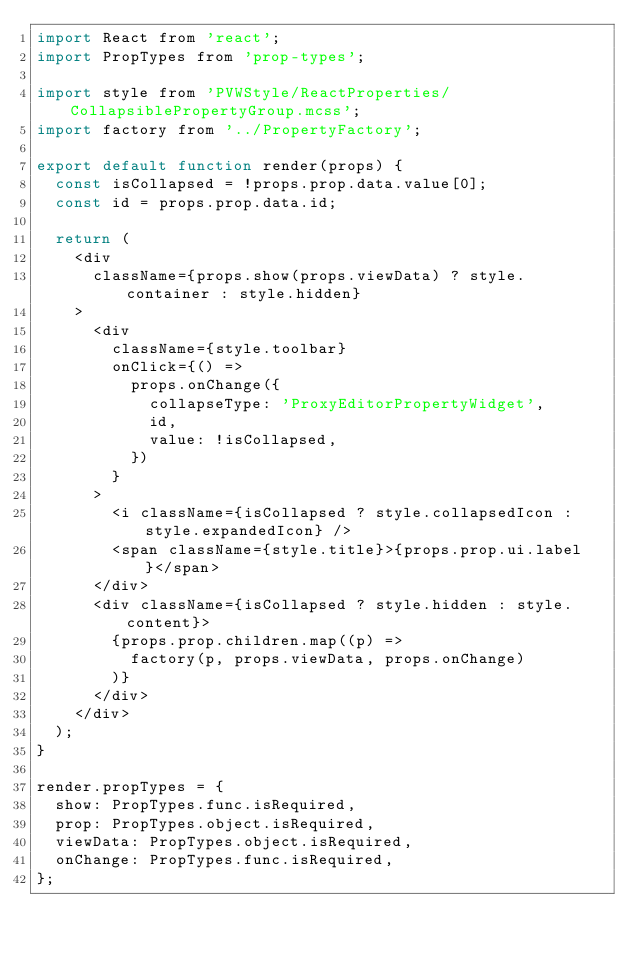Convert code to text. <code><loc_0><loc_0><loc_500><loc_500><_JavaScript_>import React from 'react';
import PropTypes from 'prop-types';

import style from 'PVWStyle/ReactProperties/CollapsiblePropertyGroup.mcss';
import factory from '../PropertyFactory';

export default function render(props) {
  const isCollapsed = !props.prop.data.value[0];
  const id = props.prop.data.id;

  return (
    <div
      className={props.show(props.viewData) ? style.container : style.hidden}
    >
      <div
        className={style.toolbar}
        onClick={() =>
          props.onChange({
            collapseType: 'ProxyEditorPropertyWidget',
            id,
            value: !isCollapsed,
          })
        }
      >
        <i className={isCollapsed ? style.collapsedIcon : style.expandedIcon} />
        <span className={style.title}>{props.prop.ui.label}</span>
      </div>
      <div className={isCollapsed ? style.hidden : style.content}>
        {props.prop.children.map((p) =>
          factory(p, props.viewData, props.onChange)
        )}
      </div>
    </div>
  );
}

render.propTypes = {
  show: PropTypes.func.isRequired,
  prop: PropTypes.object.isRequired,
  viewData: PropTypes.object.isRequired,
  onChange: PropTypes.func.isRequired,
};
</code> 